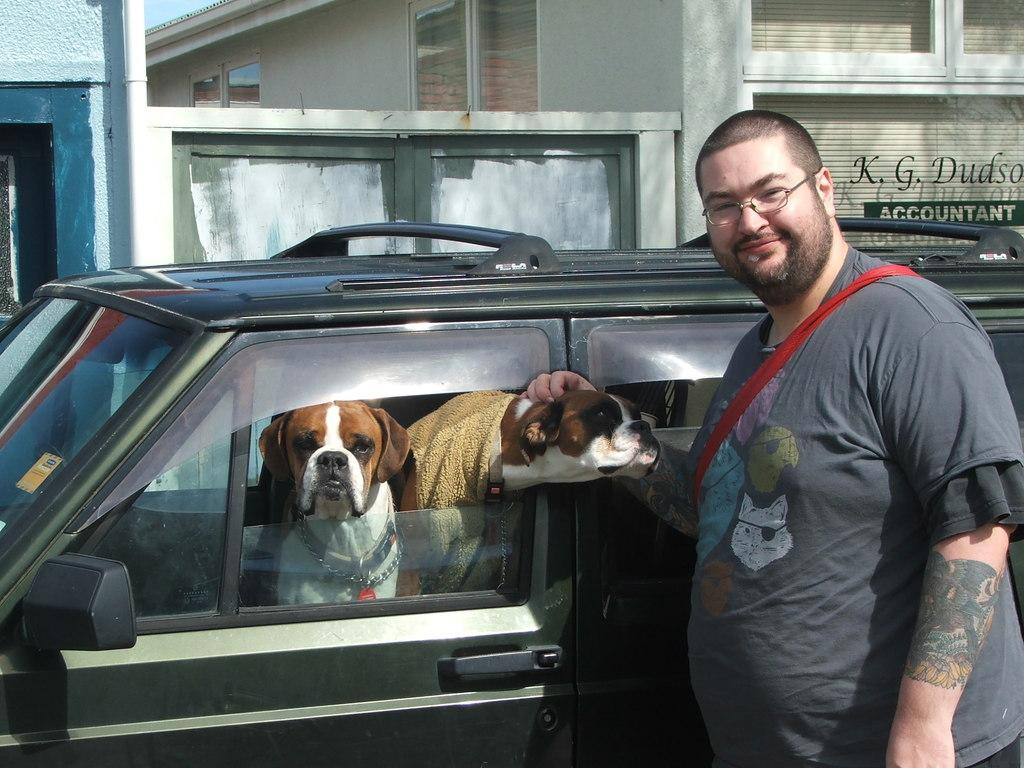What type of vehicle is in the image? There is a black car in the image. What is inside the car? There are two dogs in the car. What is the man outside the car doing? The man is standing outside the car and smiling. What is the man holding? The man is holding a dog. What can be seen in the background of the image? There is a building with windows visible in the image. What type of plane can be seen flying in the image? There is no plane visible in the image; the image features a black car, two dogs, a man, and a building. 